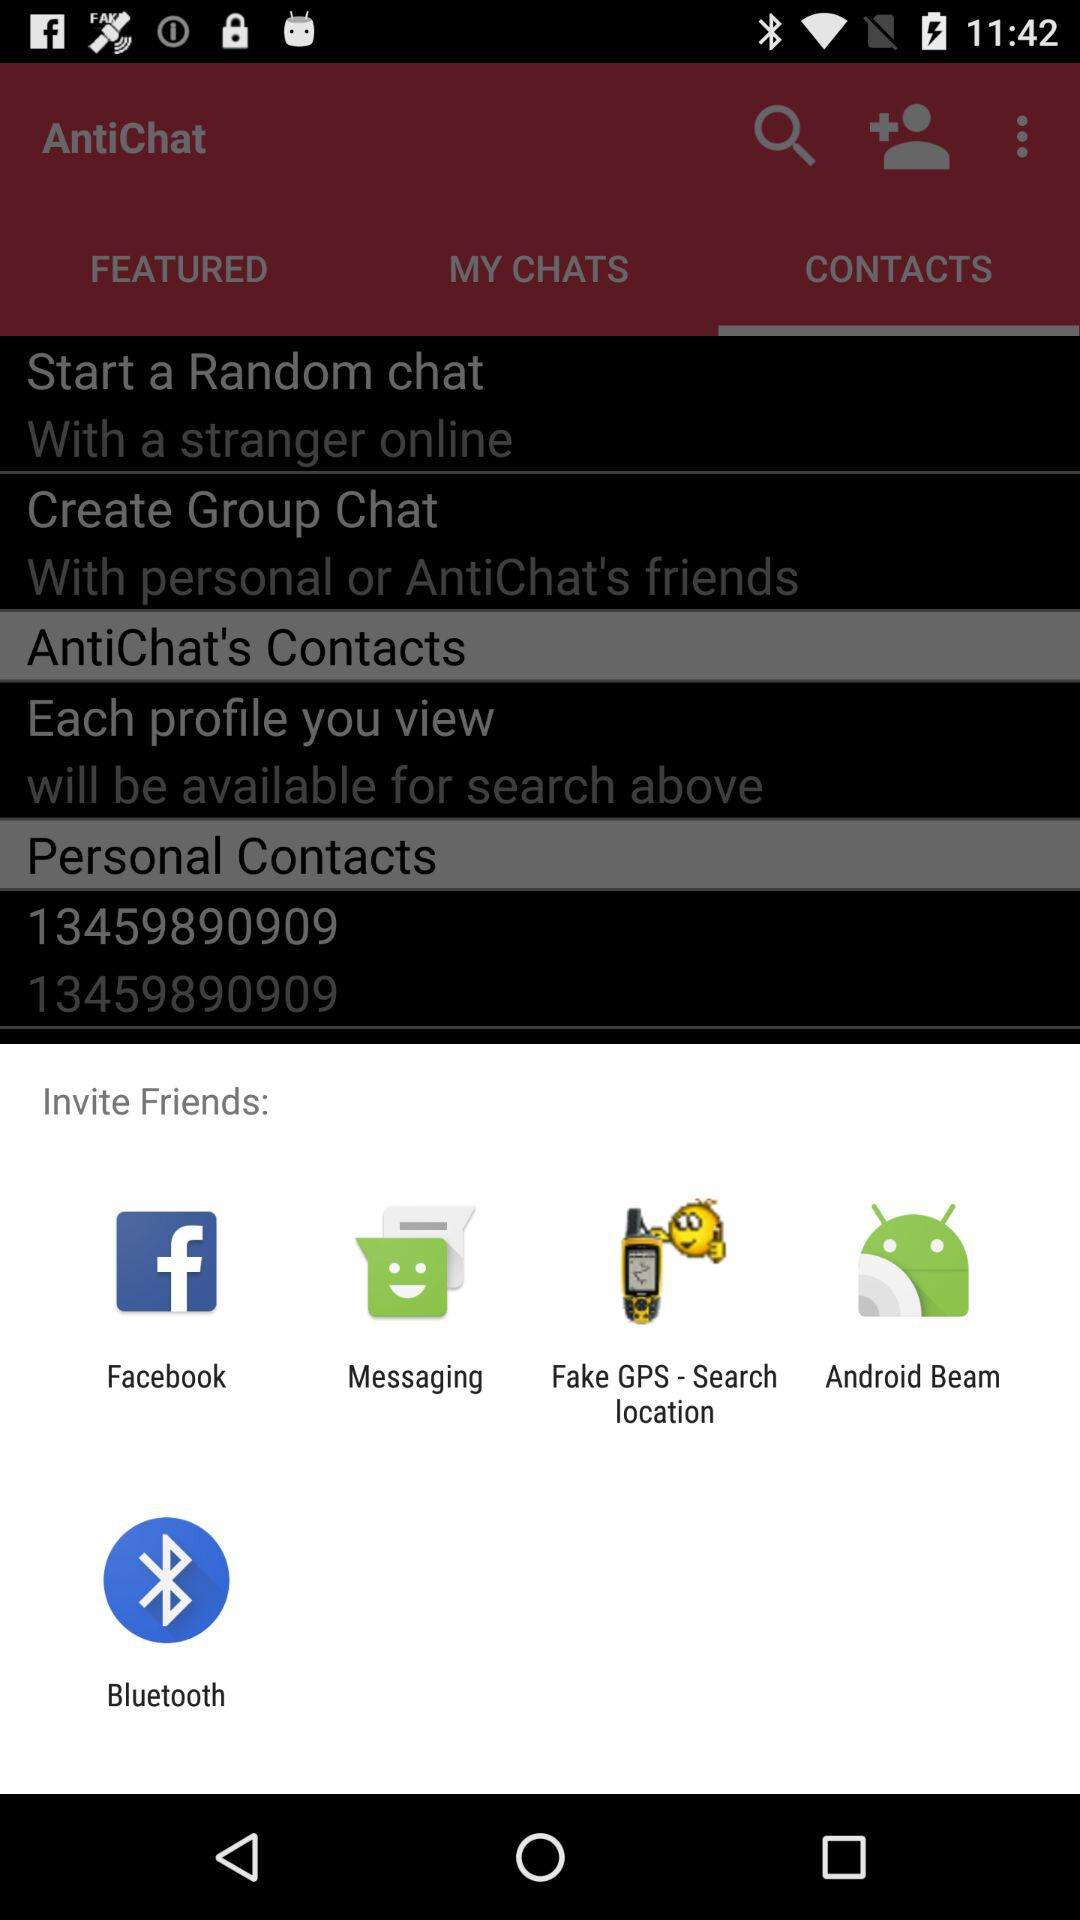What are the different applications through which can we invite friends? The different application are "Facebook", "Messaging", "Fake GPS - Search location", "Android Beam" and "Bluetooth". 